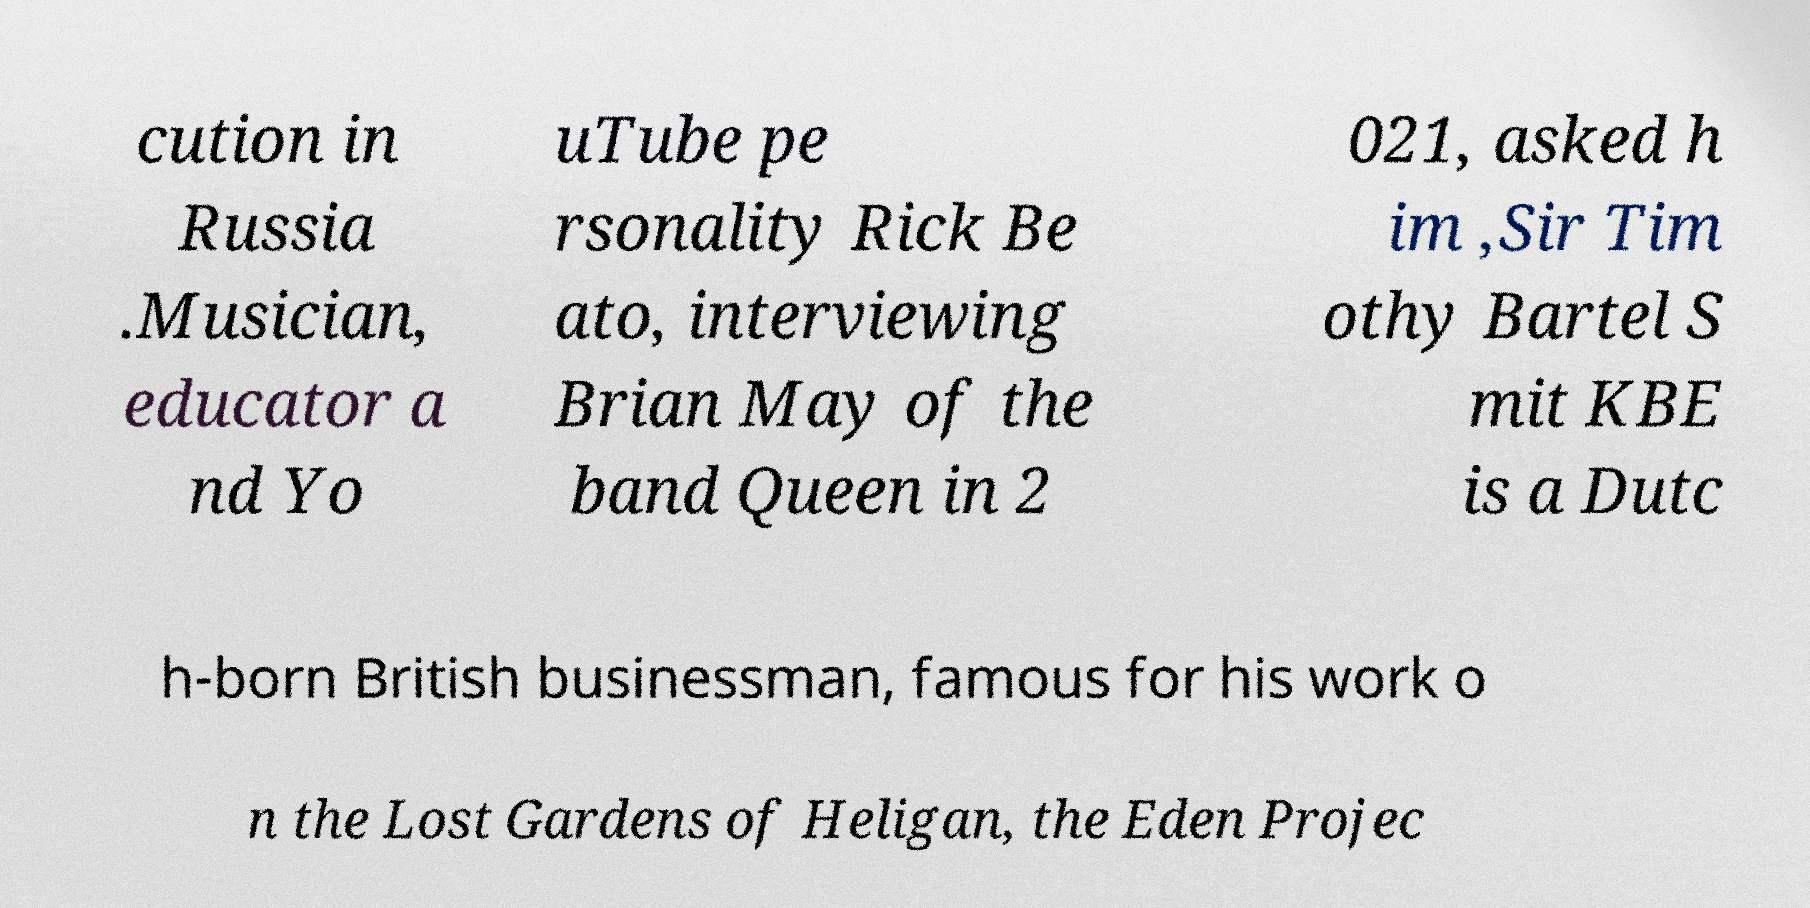What messages or text are displayed in this image? I need them in a readable, typed format. cution in Russia .Musician, educator a nd Yo uTube pe rsonality Rick Be ato, interviewing Brian May of the band Queen in 2 021, asked h im ,Sir Tim othy Bartel S mit KBE is a Dutc h-born British businessman, famous for his work o n the Lost Gardens of Heligan, the Eden Projec 